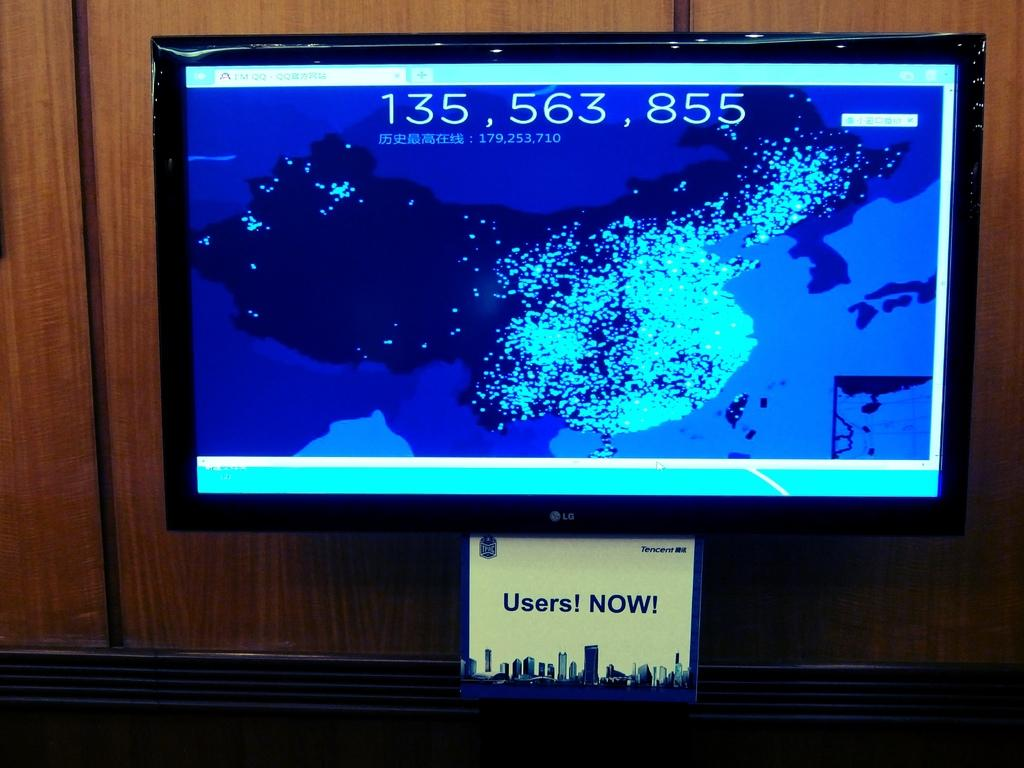<image>
Give a short and clear explanation of the subsequent image. A display with 135,563,855 users now on a blue screen. 